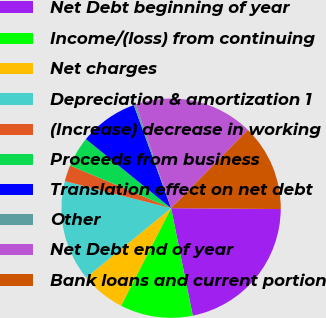Convert chart to OTSL. <chart><loc_0><loc_0><loc_500><loc_500><pie_chart><fcel>Net Debt beginning of year<fcel>Income/(loss) from continuing<fcel>Net charges<fcel>Depreciation & amortization 1<fcel>(Increase) decrease in working<fcel>Proceeds from business<fcel>Translation effect on net debt<fcel>Other<fcel>Net Debt end of year<fcel>Bank loans and current portion<nl><fcel>21.71%<fcel>10.71%<fcel>6.55%<fcel>14.87%<fcel>2.4%<fcel>4.48%<fcel>8.63%<fcel>0.32%<fcel>17.55%<fcel>12.79%<nl></chart> 